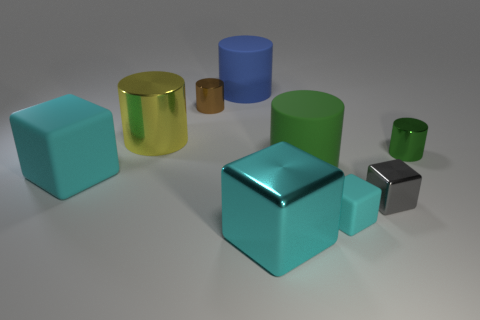The large cyan object that is made of the same material as the large yellow cylinder is what shape?
Your answer should be compact. Cube. The matte cube right of the big blue matte cylinder is what color?
Provide a short and direct response. Cyan. What material is the other big cube that is the same color as the big shiny block?
Your response must be concise. Rubber. What number of matte things are the same color as the big matte cube?
Provide a succinct answer. 1. Is the size of the cyan shiny object the same as the shiny cube that is behind the tiny matte cube?
Keep it short and to the point. No. What is the size of the block left of the big cube that is right of the large object that is behind the yellow cylinder?
Keep it short and to the point. Large. There is a large green rubber object; what number of small metal objects are on the left side of it?
Offer a terse response. 1. There is a big cyan object behind the tiny cyan object in front of the brown cylinder; what is it made of?
Make the answer very short. Rubber. Is there anything else that has the same size as the yellow shiny cylinder?
Your answer should be compact. Yes. Does the yellow object have the same size as the blue cylinder?
Keep it short and to the point. Yes. 